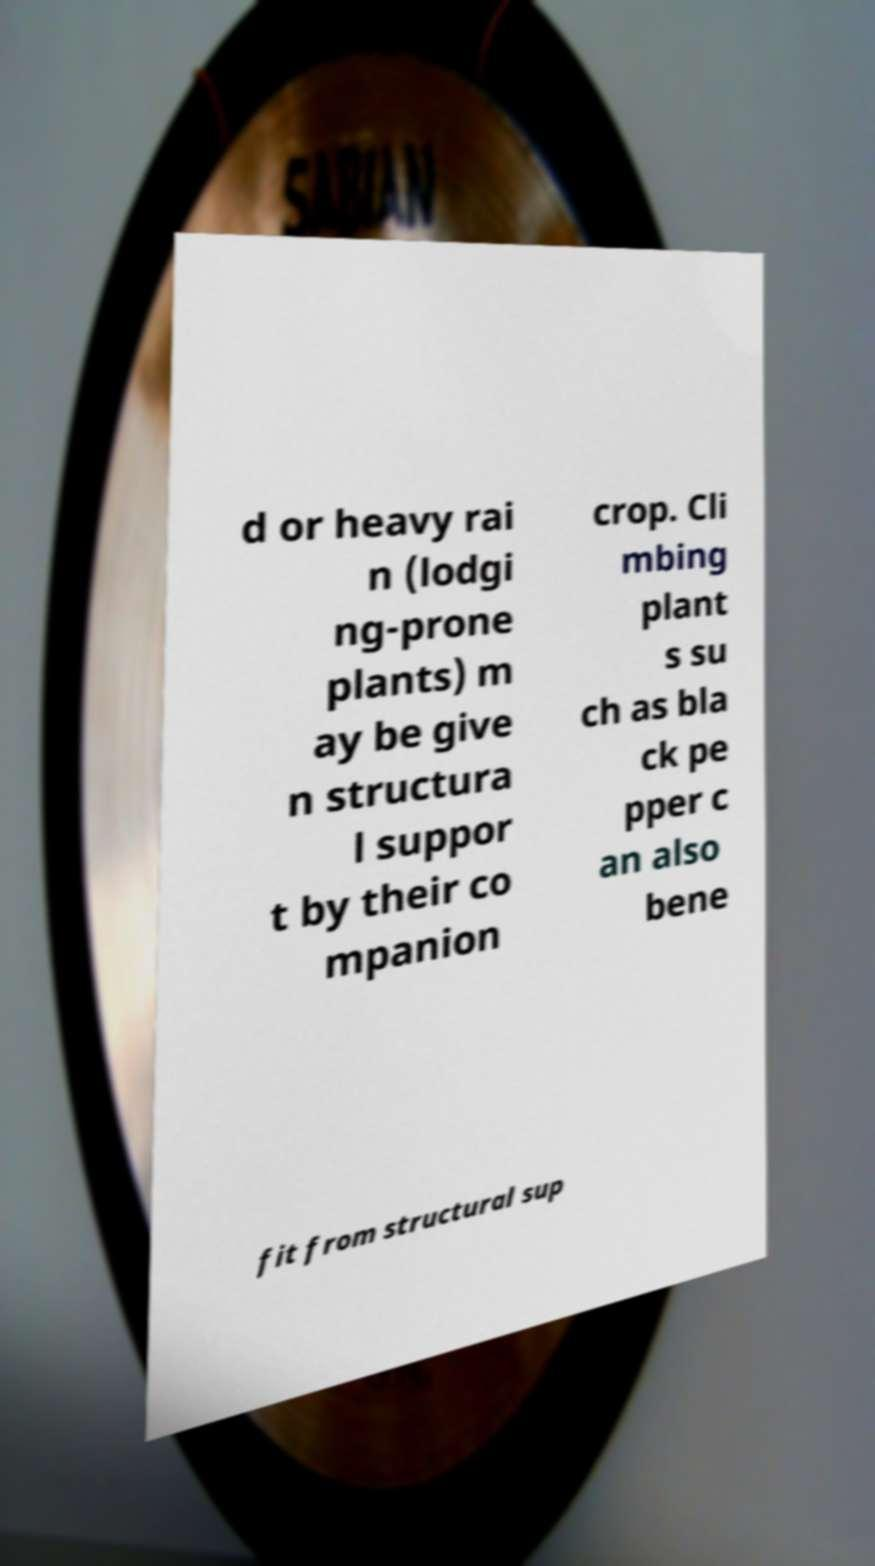Please read and relay the text visible in this image. What does it say? d or heavy rai n (lodgi ng-prone plants) m ay be give n structura l suppor t by their co mpanion crop. Cli mbing plant s su ch as bla ck pe pper c an also bene fit from structural sup 